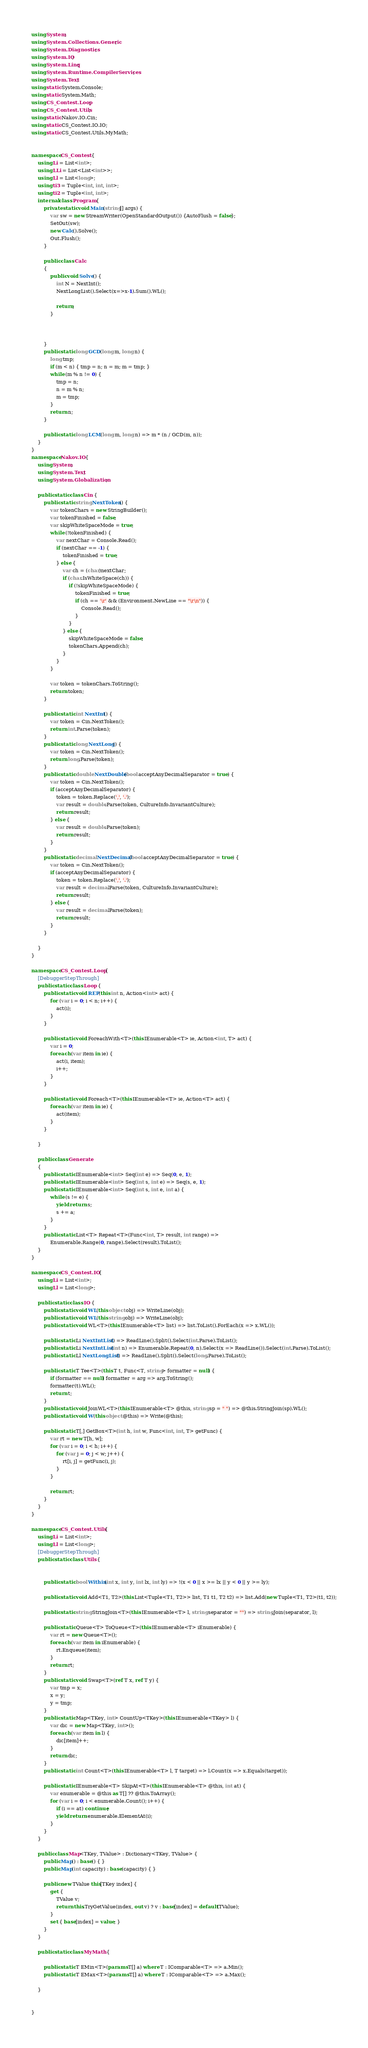Convert code to text. <code><loc_0><loc_0><loc_500><loc_500><_C#_>using System;
using System.Collections.Generic;
using System.Diagnostics;
using System.IO;
using System.Linq;
using System.Runtime.CompilerServices;
using System.Text;
using static System.Console;
using static System.Math;
using CS_Contest.Loop;
using CS_Contest.Utils;
using static Nakov.IO.Cin;
using static CS_Contest.IO.IO;
using static CS_Contest.Utils.MyMath;


namespace CS_Contest {
	using Li = List<int>;
	using LLi = List<List<int>>;
	using Ll = List<long>;
	using ti3 = Tuple<int, int, int>;
	using ti2 = Tuple<int, int>;
	internal class Program {
	    private static void Main(string[] args) {
	        var sw = new StreamWriter(OpenStandardOutput()) {AutoFlush = false};
	        SetOut(sw);
	        new Calc().Solve();
	        Out.Flush();
	    }

	    public class Calc
		{
			public void Solve() {
			    int N = NextInt();
			    NextLongList().Select(x=>x-1).Sum().WL();
			    
                return;
			}

		    

		}
	    public static long GCD(long m, long n) {
	        long tmp;
	        if (m < n) { tmp = n; n = m; m = tmp; }
	        while (m % n != 0) {
	            tmp = n;
	            n = m % n;
	            m = tmp;
	        }
	        return n;
	    }

	    public static long LCM(long m, long n) => m * (n / GCD(m, n));
    }
}
namespace Nakov.IO {
	using System;
	using System.Text;
	using System.Globalization;

	public static class Cin {
		public static string NextToken() {
			var tokenChars = new StringBuilder();
			var tokenFinished = false;
			var skipWhiteSpaceMode = true;
			while (!tokenFinished) {
				var nextChar = Console.Read();
				if (nextChar == -1) {
					tokenFinished = true;
				} else {
					var ch = (char)nextChar;
					if (char.IsWhiteSpace(ch)) {
						if (!skipWhiteSpaceMode) {
							tokenFinished = true;
							if (ch == '\r' && (Environment.NewLine == "\r\n")) {
								Console.Read();
							}
						}
					} else {
						skipWhiteSpaceMode = false;
						tokenChars.Append(ch);
					}
				}
			}

			var token = tokenChars.ToString();
			return token;
		}

		public static int NextInt() {
			var token = Cin.NextToken();
			return int.Parse(token);
		}
		public static long NextLong() {
			var token = Cin.NextToken();
			return long.Parse(token);
		}
		public static double NextDouble(bool acceptAnyDecimalSeparator = true) {
			var token = Cin.NextToken();
			if (acceptAnyDecimalSeparator) {
				token = token.Replace(',', '.');
				var result = double.Parse(token, CultureInfo.InvariantCulture);
				return result;
			} else {
				var result = double.Parse(token);
				return result;
			}
		}
		public static decimal NextDecimal(bool acceptAnyDecimalSeparator = true) {
			var token = Cin.NextToken();
			if (acceptAnyDecimalSeparator) {
				token = token.Replace(',', '.');
				var result = decimal.Parse(token, CultureInfo.InvariantCulture);
				return result;
			} else {
				var result = decimal.Parse(token);
				return result;
			}
		}

	}
}

namespace CS_Contest.Loop {
	[DebuggerStepThrough]
	public static class Loop {
		public static void REP(this int n, Action<int> act) {
			for (var i = 0; i < n; i++) {
				act(i);
			}
		}

		public static void ForeachWith<T>(this IEnumerable<T> ie, Action<int, T> act) {
			var i = 0;
			foreach (var item in ie) {
				act(i, item);
				i++;
			}
		}

		public static void Foreach<T>(this IEnumerable<T> ie, Action<T> act) {
			foreach (var item in ie) {
				act(item);
			}
		}
		
	}

	public class Generate
	{
	    public static IEnumerable<int> Seq(int e) => Seq(0, e, 1);
		public static IEnumerable<int> Seq(int s, int e) => Seq(s, e, 1);
		public static IEnumerable<int> Seq(int s, int e, int a) {
			while (s != e) {
				yield return s;
				s += a;
			}
		}
		public static List<T> Repeat<T>(Func<int, T> result, int range) =>
			Enumerable.Range(0, range).Select(result).ToList();
	}
}

namespace CS_Contest.IO {
	using Li = List<int>;
	using Ll = List<long>;

	public static class IO {
		public static void WL(this object obj) => WriteLine(obj);
		public static void WL(this string obj) => WriteLine(obj);
		public static void WL<T>(this IEnumerable<T> list) => list.ToList().ForEach(x => x.WL());

		public static Li NextIntList() => ReadLine().Split().Select(int.Parse).ToList();
		public static Li NextIntList(int n) => Enumerable.Repeat(0, n).Select(x => ReadLine()).Select(int.Parse).ToList();
		public static Ll NextLongList() => ReadLine().Split().Select(long.Parse).ToList();

		public static T Tee<T>(this T t, Func<T, string> formatter = null) {
			if (formatter == null) formatter = arg => arg.ToString();
			formatter(t).WL();
			return t;
		}
		public static void JoinWL<T>(this IEnumerable<T> @this, string sp = " ") => @this.StringJoin(sp).WL();
		public static void W(this object @this) => Write(@this);

	    public static T[,] GetBox<T>(int h, int w, Func<int, int, T> getFunc) {
	        var rt = new T[h, w];
	        for (var i = 0; i < h; i++) {
	            for (var j = 0; j < w; j++) {
	                rt[i, j] = getFunc(i, j);
	            }
	        }

	        return rt;
	    }
	}
}

namespace CS_Contest.Utils {
	using Li = List<int>;
	using Ll = List<long>;
	[DebuggerStepThrough]
	public static class Utils {
		

		public static bool Within(int x, int y, int lx, int ly) => !(x < 0 || x >= lx || y < 0 || y >= ly);

		public static void Add<T1, T2>(this List<Tuple<T1, T2>> list, T1 t1, T2 t2) => list.Add(new Tuple<T1, T2>(t1, t2));

		public static string StringJoin<T>(this IEnumerable<T> l, string separator = "") => string.Join(separator, l);

		public static Queue<T> ToQueue<T>(this IEnumerable<T> iEnumerable) {
			var rt = new Queue<T>();
			foreach (var item in iEnumerable) {
				rt.Enqueue(item);
			}
			return rt;
		}
		public static void Swap<T>(ref T x, ref T y) {
			var tmp = x;
			x = y;
			y = tmp;
		}
		public static Map<TKey, int> CountUp<TKey>(this IEnumerable<TKey> l) {
			var dic = new Map<TKey, int>();
			foreach (var item in l) {
			    dic[item]++;
			}
			return dic;
		}
		public static int Count<T>(this IEnumerable<T> l, T target) => l.Count(x => x.Equals(target));

		public static IEnumerable<T> SkipAt<T>(this IEnumerable<T> @this, int at) {
			var enumerable = @this as T[] ?? @this.ToArray();
			for (var i = 0; i < enumerable.Count(); i++) {
				if (i == at) continue;
				yield return enumerable.ElementAt(i);
			}
		}
	}

	public class Map<TKey, TValue> : Dictionary<TKey, TValue> {
		public Map() : base() { }
		public Map(int capacity) : base(capacity) { }

		public new TValue this[TKey index] {
			get {
				TValue v;
				return this.TryGetValue(index, out v) ? v : base[index] = default(TValue);
			}
			set { base[index] = value; }
		}
	}

	public static class MyMath {
		
		public static T EMin<T>(params T[] a) where T : IComparable<T> => a.Min();
		public static T EMax<T>(params T[] a) where T : IComparable<T> => a.Max();

	}


}

</code> 